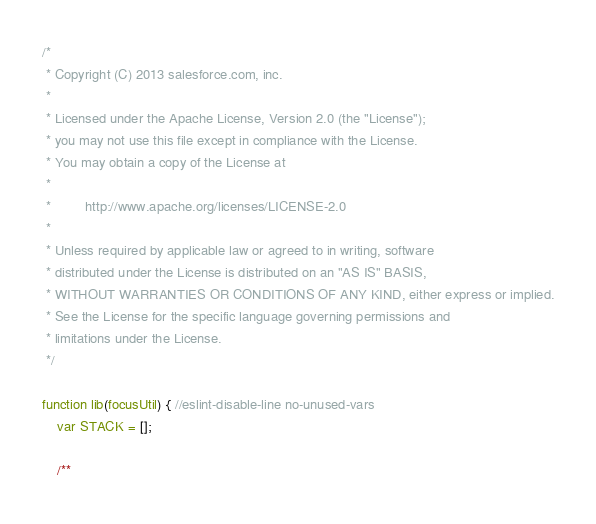Convert code to text. <code><loc_0><loc_0><loc_500><loc_500><_JavaScript_>/*
 * Copyright (C) 2013 salesforce.com, inc.
 *
 * Licensed under the Apache License, Version 2.0 (the "License");
 * you may not use this file except in compliance with the License.
 * You may obtain a copy of the License at
 *
 *         http://www.apache.org/licenses/LICENSE-2.0
 *
 * Unless required by applicable law or agreed to in writing, software
 * distributed under the License is distributed on an "AS IS" BASIS,
 * WITHOUT WARRANTIES OR CONDITIONS OF ANY KIND, either express or implied.
 * See the License for the specific language governing permissions and
 * limitations under the License.
 */

function lib(focusUtil) { //eslint-disable-line no-unused-vars
    var STACK = [];

    /**</code> 